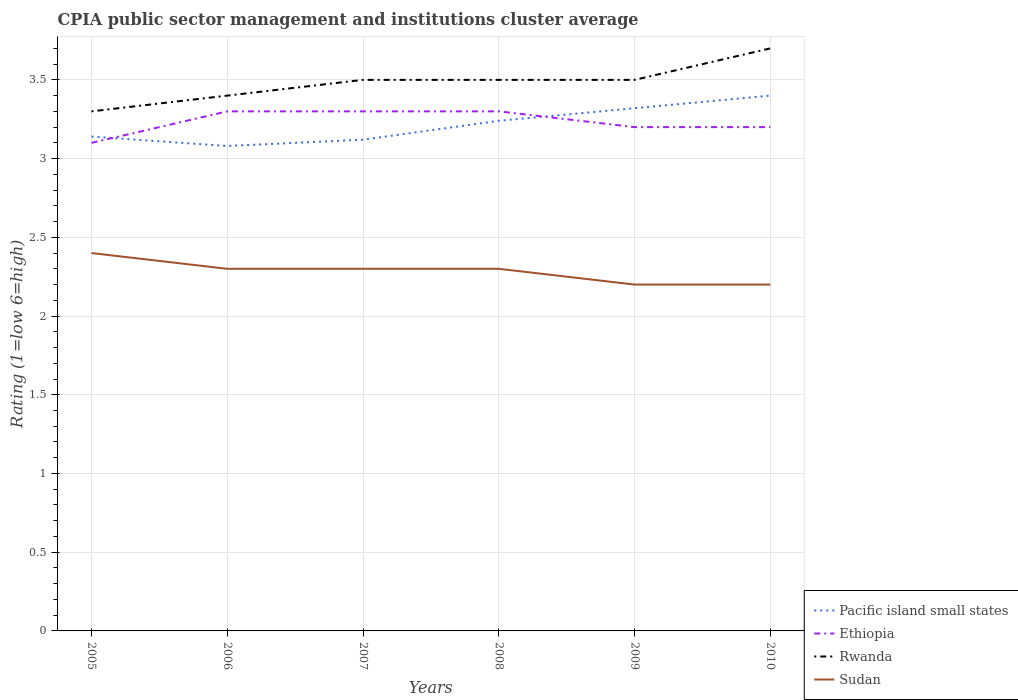Does the line corresponding to Ethiopia intersect with the line corresponding to Sudan?
Ensure brevity in your answer.  No. In which year was the CPIA rating in Sudan maximum?
Provide a succinct answer. 2009. What is the total CPIA rating in Sudan in the graph?
Give a very brief answer. 0.1. What is the difference between the highest and the second highest CPIA rating in Pacific island small states?
Offer a very short reply. 0.32. Is the CPIA rating in Rwanda strictly greater than the CPIA rating in Sudan over the years?
Keep it short and to the point. No. How many lines are there?
Provide a short and direct response. 4. What is the difference between two consecutive major ticks on the Y-axis?
Provide a short and direct response. 0.5. Where does the legend appear in the graph?
Your answer should be very brief. Bottom right. How many legend labels are there?
Keep it short and to the point. 4. How are the legend labels stacked?
Your response must be concise. Vertical. What is the title of the graph?
Offer a terse response. CPIA public sector management and institutions cluster average. What is the label or title of the X-axis?
Provide a short and direct response. Years. What is the label or title of the Y-axis?
Give a very brief answer. Rating (1=low 6=high). What is the Rating (1=low 6=high) of Pacific island small states in 2005?
Make the answer very short. 3.14. What is the Rating (1=low 6=high) of Rwanda in 2005?
Offer a very short reply. 3.3. What is the Rating (1=low 6=high) of Pacific island small states in 2006?
Make the answer very short. 3.08. What is the Rating (1=low 6=high) of Pacific island small states in 2007?
Offer a terse response. 3.12. What is the Rating (1=low 6=high) of Rwanda in 2007?
Give a very brief answer. 3.5. What is the Rating (1=low 6=high) of Pacific island small states in 2008?
Offer a terse response. 3.24. What is the Rating (1=low 6=high) in Rwanda in 2008?
Make the answer very short. 3.5. What is the Rating (1=low 6=high) in Sudan in 2008?
Provide a succinct answer. 2.3. What is the Rating (1=low 6=high) of Pacific island small states in 2009?
Provide a short and direct response. 3.32. What is the Rating (1=low 6=high) of Ethiopia in 2009?
Your response must be concise. 3.2. What is the Rating (1=low 6=high) of Rwanda in 2009?
Provide a succinct answer. 3.5. What is the Rating (1=low 6=high) in Pacific island small states in 2010?
Provide a succinct answer. 3.4. What is the Rating (1=low 6=high) of Sudan in 2010?
Your answer should be compact. 2.2. Across all years, what is the maximum Rating (1=low 6=high) in Pacific island small states?
Keep it short and to the point. 3.4. Across all years, what is the maximum Rating (1=low 6=high) of Rwanda?
Give a very brief answer. 3.7. Across all years, what is the maximum Rating (1=low 6=high) in Sudan?
Give a very brief answer. 2.4. Across all years, what is the minimum Rating (1=low 6=high) of Pacific island small states?
Your answer should be compact. 3.08. Across all years, what is the minimum Rating (1=low 6=high) in Rwanda?
Offer a very short reply. 3.3. Across all years, what is the minimum Rating (1=low 6=high) in Sudan?
Your answer should be very brief. 2.2. What is the total Rating (1=low 6=high) of Pacific island small states in the graph?
Give a very brief answer. 19.3. What is the total Rating (1=low 6=high) in Rwanda in the graph?
Give a very brief answer. 20.9. What is the difference between the Rating (1=low 6=high) of Ethiopia in 2005 and that in 2006?
Your answer should be very brief. -0.2. What is the difference between the Rating (1=low 6=high) in Pacific island small states in 2005 and that in 2007?
Provide a short and direct response. 0.02. What is the difference between the Rating (1=low 6=high) in Ethiopia in 2005 and that in 2007?
Your response must be concise. -0.2. What is the difference between the Rating (1=low 6=high) of Rwanda in 2005 and that in 2007?
Provide a succinct answer. -0.2. What is the difference between the Rating (1=low 6=high) of Sudan in 2005 and that in 2007?
Make the answer very short. 0.1. What is the difference between the Rating (1=low 6=high) of Rwanda in 2005 and that in 2008?
Provide a short and direct response. -0.2. What is the difference between the Rating (1=low 6=high) in Pacific island small states in 2005 and that in 2009?
Offer a terse response. -0.18. What is the difference between the Rating (1=low 6=high) in Rwanda in 2005 and that in 2009?
Ensure brevity in your answer.  -0.2. What is the difference between the Rating (1=low 6=high) of Pacific island small states in 2005 and that in 2010?
Offer a very short reply. -0.26. What is the difference between the Rating (1=low 6=high) of Rwanda in 2005 and that in 2010?
Offer a very short reply. -0.4. What is the difference between the Rating (1=low 6=high) in Pacific island small states in 2006 and that in 2007?
Provide a short and direct response. -0.04. What is the difference between the Rating (1=low 6=high) of Pacific island small states in 2006 and that in 2008?
Keep it short and to the point. -0.16. What is the difference between the Rating (1=low 6=high) of Rwanda in 2006 and that in 2008?
Your answer should be compact. -0.1. What is the difference between the Rating (1=low 6=high) in Sudan in 2006 and that in 2008?
Your answer should be very brief. 0. What is the difference between the Rating (1=low 6=high) in Pacific island small states in 2006 and that in 2009?
Provide a short and direct response. -0.24. What is the difference between the Rating (1=low 6=high) of Pacific island small states in 2006 and that in 2010?
Ensure brevity in your answer.  -0.32. What is the difference between the Rating (1=low 6=high) in Pacific island small states in 2007 and that in 2008?
Give a very brief answer. -0.12. What is the difference between the Rating (1=low 6=high) of Ethiopia in 2007 and that in 2008?
Your response must be concise. 0. What is the difference between the Rating (1=low 6=high) of Rwanda in 2007 and that in 2008?
Offer a terse response. 0. What is the difference between the Rating (1=low 6=high) in Ethiopia in 2007 and that in 2009?
Keep it short and to the point. 0.1. What is the difference between the Rating (1=low 6=high) of Rwanda in 2007 and that in 2009?
Make the answer very short. 0. What is the difference between the Rating (1=low 6=high) in Sudan in 2007 and that in 2009?
Your answer should be very brief. 0.1. What is the difference between the Rating (1=low 6=high) of Pacific island small states in 2007 and that in 2010?
Offer a very short reply. -0.28. What is the difference between the Rating (1=low 6=high) in Rwanda in 2007 and that in 2010?
Your answer should be compact. -0.2. What is the difference between the Rating (1=low 6=high) in Pacific island small states in 2008 and that in 2009?
Offer a terse response. -0.08. What is the difference between the Rating (1=low 6=high) in Rwanda in 2008 and that in 2009?
Your answer should be very brief. 0. What is the difference between the Rating (1=low 6=high) in Pacific island small states in 2008 and that in 2010?
Give a very brief answer. -0.16. What is the difference between the Rating (1=low 6=high) of Ethiopia in 2008 and that in 2010?
Offer a terse response. 0.1. What is the difference between the Rating (1=low 6=high) in Rwanda in 2008 and that in 2010?
Provide a short and direct response. -0.2. What is the difference between the Rating (1=low 6=high) in Sudan in 2008 and that in 2010?
Provide a succinct answer. 0.1. What is the difference between the Rating (1=low 6=high) of Pacific island small states in 2009 and that in 2010?
Your answer should be very brief. -0.08. What is the difference between the Rating (1=low 6=high) of Rwanda in 2009 and that in 2010?
Ensure brevity in your answer.  -0.2. What is the difference between the Rating (1=low 6=high) of Sudan in 2009 and that in 2010?
Your answer should be very brief. 0. What is the difference between the Rating (1=low 6=high) in Pacific island small states in 2005 and the Rating (1=low 6=high) in Ethiopia in 2006?
Ensure brevity in your answer.  -0.16. What is the difference between the Rating (1=low 6=high) in Pacific island small states in 2005 and the Rating (1=low 6=high) in Rwanda in 2006?
Make the answer very short. -0.26. What is the difference between the Rating (1=low 6=high) in Pacific island small states in 2005 and the Rating (1=low 6=high) in Sudan in 2006?
Give a very brief answer. 0.84. What is the difference between the Rating (1=low 6=high) of Ethiopia in 2005 and the Rating (1=low 6=high) of Rwanda in 2006?
Make the answer very short. -0.3. What is the difference between the Rating (1=low 6=high) of Ethiopia in 2005 and the Rating (1=low 6=high) of Sudan in 2006?
Provide a short and direct response. 0.8. What is the difference between the Rating (1=low 6=high) of Rwanda in 2005 and the Rating (1=low 6=high) of Sudan in 2006?
Offer a very short reply. 1. What is the difference between the Rating (1=low 6=high) of Pacific island small states in 2005 and the Rating (1=low 6=high) of Ethiopia in 2007?
Your answer should be compact. -0.16. What is the difference between the Rating (1=low 6=high) of Pacific island small states in 2005 and the Rating (1=low 6=high) of Rwanda in 2007?
Offer a very short reply. -0.36. What is the difference between the Rating (1=low 6=high) of Pacific island small states in 2005 and the Rating (1=low 6=high) of Sudan in 2007?
Ensure brevity in your answer.  0.84. What is the difference between the Rating (1=low 6=high) in Pacific island small states in 2005 and the Rating (1=low 6=high) in Ethiopia in 2008?
Keep it short and to the point. -0.16. What is the difference between the Rating (1=low 6=high) of Pacific island small states in 2005 and the Rating (1=low 6=high) of Rwanda in 2008?
Ensure brevity in your answer.  -0.36. What is the difference between the Rating (1=low 6=high) of Pacific island small states in 2005 and the Rating (1=low 6=high) of Sudan in 2008?
Provide a short and direct response. 0.84. What is the difference between the Rating (1=low 6=high) in Ethiopia in 2005 and the Rating (1=low 6=high) in Rwanda in 2008?
Your response must be concise. -0.4. What is the difference between the Rating (1=low 6=high) of Ethiopia in 2005 and the Rating (1=low 6=high) of Sudan in 2008?
Give a very brief answer. 0.8. What is the difference between the Rating (1=low 6=high) in Pacific island small states in 2005 and the Rating (1=low 6=high) in Ethiopia in 2009?
Provide a short and direct response. -0.06. What is the difference between the Rating (1=low 6=high) in Pacific island small states in 2005 and the Rating (1=low 6=high) in Rwanda in 2009?
Offer a very short reply. -0.36. What is the difference between the Rating (1=low 6=high) in Pacific island small states in 2005 and the Rating (1=low 6=high) in Sudan in 2009?
Your response must be concise. 0.94. What is the difference between the Rating (1=low 6=high) of Ethiopia in 2005 and the Rating (1=low 6=high) of Sudan in 2009?
Offer a very short reply. 0.9. What is the difference between the Rating (1=low 6=high) in Pacific island small states in 2005 and the Rating (1=low 6=high) in Ethiopia in 2010?
Provide a succinct answer. -0.06. What is the difference between the Rating (1=low 6=high) of Pacific island small states in 2005 and the Rating (1=low 6=high) of Rwanda in 2010?
Your answer should be very brief. -0.56. What is the difference between the Rating (1=low 6=high) of Ethiopia in 2005 and the Rating (1=low 6=high) of Sudan in 2010?
Offer a very short reply. 0.9. What is the difference between the Rating (1=low 6=high) in Rwanda in 2005 and the Rating (1=low 6=high) in Sudan in 2010?
Provide a short and direct response. 1.1. What is the difference between the Rating (1=low 6=high) in Pacific island small states in 2006 and the Rating (1=low 6=high) in Ethiopia in 2007?
Ensure brevity in your answer.  -0.22. What is the difference between the Rating (1=low 6=high) of Pacific island small states in 2006 and the Rating (1=low 6=high) of Rwanda in 2007?
Keep it short and to the point. -0.42. What is the difference between the Rating (1=low 6=high) in Pacific island small states in 2006 and the Rating (1=low 6=high) in Sudan in 2007?
Offer a very short reply. 0.78. What is the difference between the Rating (1=low 6=high) of Ethiopia in 2006 and the Rating (1=low 6=high) of Rwanda in 2007?
Your answer should be compact. -0.2. What is the difference between the Rating (1=low 6=high) of Rwanda in 2006 and the Rating (1=low 6=high) of Sudan in 2007?
Give a very brief answer. 1.1. What is the difference between the Rating (1=low 6=high) in Pacific island small states in 2006 and the Rating (1=low 6=high) in Ethiopia in 2008?
Give a very brief answer. -0.22. What is the difference between the Rating (1=low 6=high) in Pacific island small states in 2006 and the Rating (1=low 6=high) in Rwanda in 2008?
Offer a terse response. -0.42. What is the difference between the Rating (1=low 6=high) of Pacific island small states in 2006 and the Rating (1=low 6=high) of Sudan in 2008?
Your answer should be very brief. 0.78. What is the difference between the Rating (1=low 6=high) in Pacific island small states in 2006 and the Rating (1=low 6=high) in Ethiopia in 2009?
Make the answer very short. -0.12. What is the difference between the Rating (1=low 6=high) of Pacific island small states in 2006 and the Rating (1=low 6=high) of Rwanda in 2009?
Offer a very short reply. -0.42. What is the difference between the Rating (1=low 6=high) of Pacific island small states in 2006 and the Rating (1=low 6=high) of Ethiopia in 2010?
Provide a succinct answer. -0.12. What is the difference between the Rating (1=low 6=high) in Pacific island small states in 2006 and the Rating (1=low 6=high) in Rwanda in 2010?
Your answer should be very brief. -0.62. What is the difference between the Rating (1=low 6=high) in Pacific island small states in 2006 and the Rating (1=low 6=high) in Sudan in 2010?
Offer a very short reply. 0.88. What is the difference between the Rating (1=low 6=high) of Rwanda in 2006 and the Rating (1=low 6=high) of Sudan in 2010?
Offer a terse response. 1.2. What is the difference between the Rating (1=low 6=high) of Pacific island small states in 2007 and the Rating (1=low 6=high) of Ethiopia in 2008?
Provide a short and direct response. -0.18. What is the difference between the Rating (1=low 6=high) in Pacific island small states in 2007 and the Rating (1=low 6=high) in Rwanda in 2008?
Keep it short and to the point. -0.38. What is the difference between the Rating (1=low 6=high) in Pacific island small states in 2007 and the Rating (1=low 6=high) in Sudan in 2008?
Provide a succinct answer. 0.82. What is the difference between the Rating (1=low 6=high) of Rwanda in 2007 and the Rating (1=low 6=high) of Sudan in 2008?
Your answer should be compact. 1.2. What is the difference between the Rating (1=low 6=high) of Pacific island small states in 2007 and the Rating (1=low 6=high) of Ethiopia in 2009?
Ensure brevity in your answer.  -0.08. What is the difference between the Rating (1=low 6=high) in Pacific island small states in 2007 and the Rating (1=low 6=high) in Rwanda in 2009?
Keep it short and to the point. -0.38. What is the difference between the Rating (1=low 6=high) of Pacific island small states in 2007 and the Rating (1=low 6=high) of Sudan in 2009?
Provide a short and direct response. 0.92. What is the difference between the Rating (1=low 6=high) of Ethiopia in 2007 and the Rating (1=low 6=high) of Sudan in 2009?
Your answer should be very brief. 1.1. What is the difference between the Rating (1=low 6=high) of Rwanda in 2007 and the Rating (1=low 6=high) of Sudan in 2009?
Provide a short and direct response. 1.3. What is the difference between the Rating (1=low 6=high) of Pacific island small states in 2007 and the Rating (1=low 6=high) of Ethiopia in 2010?
Ensure brevity in your answer.  -0.08. What is the difference between the Rating (1=low 6=high) of Pacific island small states in 2007 and the Rating (1=low 6=high) of Rwanda in 2010?
Your response must be concise. -0.58. What is the difference between the Rating (1=low 6=high) of Pacific island small states in 2007 and the Rating (1=low 6=high) of Sudan in 2010?
Provide a succinct answer. 0.92. What is the difference between the Rating (1=low 6=high) of Ethiopia in 2007 and the Rating (1=low 6=high) of Rwanda in 2010?
Provide a short and direct response. -0.4. What is the difference between the Rating (1=low 6=high) in Ethiopia in 2007 and the Rating (1=low 6=high) in Sudan in 2010?
Provide a short and direct response. 1.1. What is the difference between the Rating (1=low 6=high) in Pacific island small states in 2008 and the Rating (1=low 6=high) in Rwanda in 2009?
Provide a short and direct response. -0.26. What is the difference between the Rating (1=low 6=high) of Ethiopia in 2008 and the Rating (1=low 6=high) of Sudan in 2009?
Your answer should be very brief. 1.1. What is the difference between the Rating (1=low 6=high) of Pacific island small states in 2008 and the Rating (1=low 6=high) of Rwanda in 2010?
Provide a succinct answer. -0.46. What is the difference between the Rating (1=low 6=high) of Pacific island small states in 2009 and the Rating (1=low 6=high) of Ethiopia in 2010?
Give a very brief answer. 0.12. What is the difference between the Rating (1=low 6=high) in Pacific island small states in 2009 and the Rating (1=low 6=high) in Rwanda in 2010?
Your response must be concise. -0.38. What is the difference between the Rating (1=low 6=high) in Pacific island small states in 2009 and the Rating (1=low 6=high) in Sudan in 2010?
Your response must be concise. 1.12. What is the difference between the Rating (1=low 6=high) of Ethiopia in 2009 and the Rating (1=low 6=high) of Sudan in 2010?
Your answer should be compact. 1. What is the difference between the Rating (1=low 6=high) in Rwanda in 2009 and the Rating (1=low 6=high) in Sudan in 2010?
Your answer should be very brief. 1.3. What is the average Rating (1=low 6=high) of Pacific island small states per year?
Provide a short and direct response. 3.22. What is the average Rating (1=low 6=high) of Ethiopia per year?
Provide a short and direct response. 3.23. What is the average Rating (1=low 6=high) in Rwanda per year?
Offer a terse response. 3.48. What is the average Rating (1=low 6=high) of Sudan per year?
Keep it short and to the point. 2.28. In the year 2005, what is the difference between the Rating (1=low 6=high) of Pacific island small states and Rating (1=low 6=high) of Ethiopia?
Provide a short and direct response. 0.04. In the year 2005, what is the difference between the Rating (1=low 6=high) in Pacific island small states and Rating (1=low 6=high) in Rwanda?
Offer a very short reply. -0.16. In the year 2005, what is the difference between the Rating (1=low 6=high) in Pacific island small states and Rating (1=low 6=high) in Sudan?
Offer a terse response. 0.74. In the year 2005, what is the difference between the Rating (1=low 6=high) in Ethiopia and Rating (1=low 6=high) in Rwanda?
Your answer should be compact. -0.2. In the year 2005, what is the difference between the Rating (1=low 6=high) of Ethiopia and Rating (1=low 6=high) of Sudan?
Make the answer very short. 0.7. In the year 2006, what is the difference between the Rating (1=low 6=high) of Pacific island small states and Rating (1=low 6=high) of Ethiopia?
Offer a very short reply. -0.22. In the year 2006, what is the difference between the Rating (1=low 6=high) in Pacific island small states and Rating (1=low 6=high) in Rwanda?
Ensure brevity in your answer.  -0.32. In the year 2006, what is the difference between the Rating (1=low 6=high) of Pacific island small states and Rating (1=low 6=high) of Sudan?
Ensure brevity in your answer.  0.78. In the year 2006, what is the difference between the Rating (1=low 6=high) of Ethiopia and Rating (1=low 6=high) of Rwanda?
Offer a very short reply. -0.1. In the year 2007, what is the difference between the Rating (1=low 6=high) of Pacific island small states and Rating (1=low 6=high) of Ethiopia?
Keep it short and to the point. -0.18. In the year 2007, what is the difference between the Rating (1=low 6=high) of Pacific island small states and Rating (1=low 6=high) of Rwanda?
Your response must be concise. -0.38. In the year 2007, what is the difference between the Rating (1=low 6=high) in Pacific island small states and Rating (1=low 6=high) in Sudan?
Offer a very short reply. 0.82. In the year 2007, what is the difference between the Rating (1=low 6=high) in Ethiopia and Rating (1=low 6=high) in Rwanda?
Give a very brief answer. -0.2. In the year 2007, what is the difference between the Rating (1=low 6=high) in Ethiopia and Rating (1=low 6=high) in Sudan?
Your answer should be compact. 1. In the year 2007, what is the difference between the Rating (1=low 6=high) of Rwanda and Rating (1=low 6=high) of Sudan?
Ensure brevity in your answer.  1.2. In the year 2008, what is the difference between the Rating (1=low 6=high) of Pacific island small states and Rating (1=low 6=high) of Ethiopia?
Offer a terse response. -0.06. In the year 2008, what is the difference between the Rating (1=low 6=high) of Pacific island small states and Rating (1=low 6=high) of Rwanda?
Give a very brief answer. -0.26. In the year 2008, what is the difference between the Rating (1=low 6=high) in Pacific island small states and Rating (1=low 6=high) in Sudan?
Your answer should be very brief. 0.94. In the year 2008, what is the difference between the Rating (1=low 6=high) of Ethiopia and Rating (1=low 6=high) of Sudan?
Ensure brevity in your answer.  1. In the year 2008, what is the difference between the Rating (1=low 6=high) in Rwanda and Rating (1=low 6=high) in Sudan?
Give a very brief answer. 1.2. In the year 2009, what is the difference between the Rating (1=low 6=high) in Pacific island small states and Rating (1=low 6=high) in Ethiopia?
Make the answer very short. 0.12. In the year 2009, what is the difference between the Rating (1=low 6=high) in Pacific island small states and Rating (1=low 6=high) in Rwanda?
Your answer should be compact. -0.18. In the year 2009, what is the difference between the Rating (1=low 6=high) in Pacific island small states and Rating (1=low 6=high) in Sudan?
Offer a very short reply. 1.12. In the year 2009, what is the difference between the Rating (1=low 6=high) of Ethiopia and Rating (1=low 6=high) of Sudan?
Your response must be concise. 1. In the year 2009, what is the difference between the Rating (1=low 6=high) of Rwanda and Rating (1=low 6=high) of Sudan?
Make the answer very short. 1.3. In the year 2010, what is the difference between the Rating (1=low 6=high) of Ethiopia and Rating (1=low 6=high) of Rwanda?
Your answer should be very brief. -0.5. In the year 2010, what is the difference between the Rating (1=low 6=high) of Rwanda and Rating (1=low 6=high) of Sudan?
Provide a succinct answer. 1.5. What is the ratio of the Rating (1=low 6=high) in Pacific island small states in 2005 to that in 2006?
Your answer should be very brief. 1.02. What is the ratio of the Rating (1=low 6=high) in Ethiopia in 2005 to that in 2006?
Your response must be concise. 0.94. What is the ratio of the Rating (1=low 6=high) in Rwanda in 2005 to that in 2006?
Make the answer very short. 0.97. What is the ratio of the Rating (1=low 6=high) in Sudan in 2005 to that in 2006?
Your answer should be compact. 1.04. What is the ratio of the Rating (1=low 6=high) of Pacific island small states in 2005 to that in 2007?
Your answer should be very brief. 1.01. What is the ratio of the Rating (1=low 6=high) of Ethiopia in 2005 to that in 2007?
Your answer should be compact. 0.94. What is the ratio of the Rating (1=low 6=high) of Rwanda in 2005 to that in 2007?
Provide a succinct answer. 0.94. What is the ratio of the Rating (1=low 6=high) of Sudan in 2005 to that in 2007?
Your answer should be very brief. 1.04. What is the ratio of the Rating (1=low 6=high) in Pacific island small states in 2005 to that in 2008?
Your response must be concise. 0.97. What is the ratio of the Rating (1=low 6=high) in Ethiopia in 2005 to that in 2008?
Give a very brief answer. 0.94. What is the ratio of the Rating (1=low 6=high) in Rwanda in 2005 to that in 2008?
Provide a succinct answer. 0.94. What is the ratio of the Rating (1=low 6=high) in Sudan in 2005 to that in 2008?
Offer a very short reply. 1.04. What is the ratio of the Rating (1=low 6=high) of Pacific island small states in 2005 to that in 2009?
Provide a succinct answer. 0.95. What is the ratio of the Rating (1=low 6=high) of Ethiopia in 2005 to that in 2009?
Your answer should be compact. 0.97. What is the ratio of the Rating (1=low 6=high) of Rwanda in 2005 to that in 2009?
Provide a succinct answer. 0.94. What is the ratio of the Rating (1=low 6=high) of Pacific island small states in 2005 to that in 2010?
Give a very brief answer. 0.92. What is the ratio of the Rating (1=low 6=high) of Ethiopia in 2005 to that in 2010?
Ensure brevity in your answer.  0.97. What is the ratio of the Rating (1=low 6=high) in Rwanda in 2005 to that in 2010?
Offer a terse response. 0.89. What is the ratio of the Rating (1=low 6=high) in Sudan in 2005 to that in 2010?
Your answer should be compact. 1.09. What is the ratio of the Rating (1=low 6=high) in Pacific island small states in 2006 to that in 2007?
Offer a terse response. 0.99. What is the ratio of the Rating (1=low 6=high) of Rwanda in 2006 to that in 2007?
Keep it short and to the point. 0.97. What is the ratio of the Rating (1=low 6=high) in Sudan in 2006 to that in 2007?
Provide a succinct answer. 1. What is the ratio of the Rating (1=low 6=high) of Pacific island small states in 2006 to that in 2008?
Make the answer very short. 0.95. What is the ratio of the Rating (1=low 6=high) in Ethiopia in 2006 to that in 2008?
Make the answer very short. 1. What is the ratio of the Rating (1=low 6=high) in Rwanda in 2006 to that in 2008?
Offer a very short reply. 0.97. What is the ratio of the Rating (1=low 6=high) in Pacific island small states in 2006 to that in 2009?
Your answer should be compact. 0.93. What is the ratio of the Rating (1=low 6=high) of Ethiopia in 2006 to that in 2009?
Provide a short and direct response. 1.03. What is the ratio of the Rating (1=low 6=high) in Rwanda in 2006 to that in 2009?
Your answer should be compact. 0.97. What is the ratio of the Rating (1=low 6=high) in Sudan in 2006 to that in 2009?
Your answer should be compact. 1.05. What is the ratio of the Rating (1=low 6=high) of Pacific island small states in 2006 to that in 2010?
Make the answer very short. 0.91. What is the ratio of the Rating (1=low 6=high) of Ethiopia in 2006 to that in 2010?
Your answer should be compact. 1.03. What is the ratio of the Rating (1=low 6=high) in Rwanda in 2006 to that in 2010?
Your answer should be compact. 0.92. What is the ratio of the Rating (1=low 6=high) in Sudan in 2006 to that in 2010?
Give a very brief answer. 1.05. What is the ratio of the Rating (1=low 6=high) of Ethiopia in 2007 to that in 2008?
Offer a very short reply. 1. What is the ratio of the Rating (1=low 6=high) in Rwanda in 2007 to that in 2008?
Your answer should be compact. 1. What is the ratio of the Rating (1=low 6=high) in Pacific island small states in 2007 to that in 2009?
Provide a succinct answer. 0.94. What is the ratio of the Rating (1=low 6=high) in Ethiopia in 2007 to that in 2009?
Your answer should be compact. 1.03. What is the ratio of the Rating (1=low 6=high) in Rwanda in 2007 to that in 2009?
Your answer should be compact. 1. What is the ratio of the Rating (1=low 6=high) in Sudan in 2007 to that in 2009?
Make the answer very short. 1.05. What is the ratio of the Rating (1=low 6=high) of Pacific island small states in 2007 to that in 2010?
Provide a succinct answer. 0.92. What is the ratio of the Rating (1=low 6=high) of Ethiopia in 2007 to that in 2010?
Make the answer very short. 1.03. What is the ratio of the Rating (1=low 6=high) in Rwanda in 2007 to that in 2010?
Offer a very short reply. 0.95. What is the ratio of the Rating (1=low 6=high) in Sudan in 2007 to that in 2010?
Your answer should be compact. 1.05. What is the ratio of the Rating (1=low 6=high) in Pacific island small states in 2008 to that in 2009?
Provide a short and direct response. 0.98. What is the ratio of the Rating (1=low 6=high) in Ethiopia in 2008 to that in 2009?
Offer a very short reply. 1.03. What is the ratio of the Rating (1=low 6=high) in Rwanda in 2008 to that in 2009?
Your response must be concise. 1. What is the ratio of the Rating (1=low 6=high) in Sudan in 2008 to that in 2009?
Your answer should be compact. 1.05. What is the ratio of the Rating (1=low 6=high) of Pacific island small states in 2008 to that in 2010?
Your response must be concise. 0.95. What is the ratio of the Rating (1=low 6=high) of Ethiopia in 2008 to that in 2010?
Keep it short and to the point. 1.03. What is the ratio of the Rating (1=low 6=high) of Rwanda in 2008 to that in 2010?
Offer a very short reply. 0.95. What is the ratio of the Rating (1=low 6=high) in Sudan in 2008 to that in 2010?
Provide a short and direct response. 1.05. What is the ratio of the Rating (1=low 6=high) in Pacific island small states in 2009 to that in 2010?
Provide a short and direct response. 0.98. What is the ratio of the Rating (1=low 6=high) of Ethiopia in 2009 to that in 2010?
Offer a very short reply. 1. What is the ratio of the Rating (1=low 6=high) of Rwanda in 2009 to that in 2010?
Make the answer very short. 0.95. What is the difference between the highest and the lowest Rating (1=low 6=high) of Pacific island small states?
Provide a succinct answer. 0.32. What is the difference between the highest and the lowest Rating (1=low 6=high) in Rwanda?
Your answer should be very brief. 0.4. What is the difference between the highest and the lowest Rating (1=low 6=high) in Sudan?
Offer a very short reply. 0.2. 